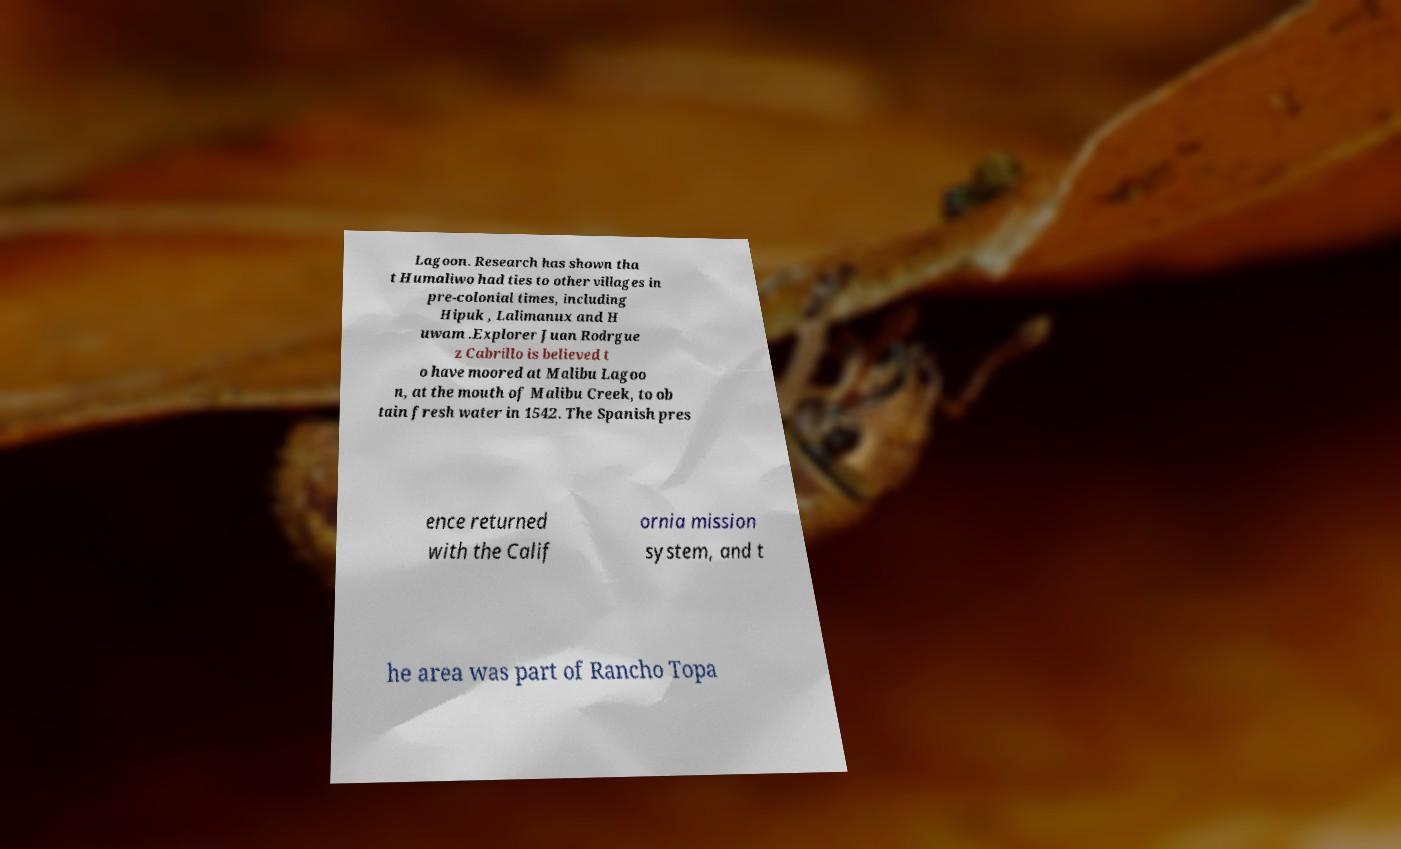What messages or text are displayed in this image? I need them in a readable, typed format. Lagoon. Research has shown tha t Humaliwo had ties to other villages in pre-colonial times, including Hipuk , Lalimanux and H uwam .Explorer Juan Rodrgue z Cabrillo is believed t o have moored at Malibu Lagoo n, at the mouth of Malibu Creek, to ob tain fresh water in 1542. The Spanish pres ence returned with the Calif ornia mission system, and t he area was part of Rancho Topa 